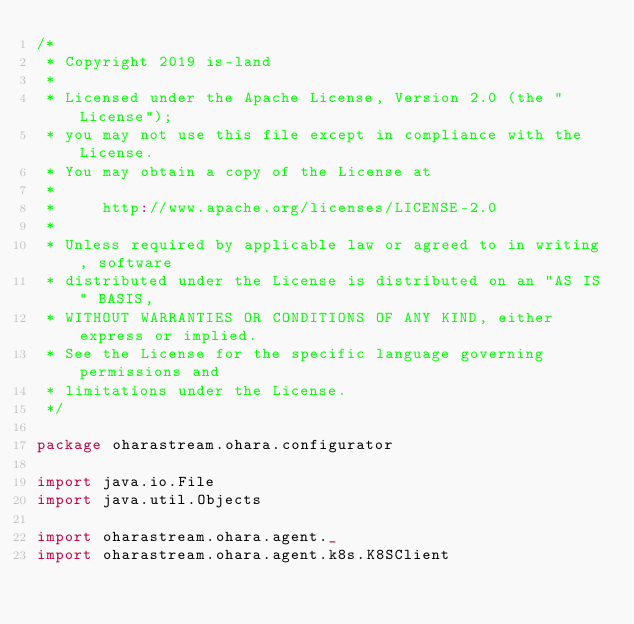<code> <loc_0><loc_0><loc_500><loc_500><_Scala_>/*
 * Copyright 2019 is-land
 *
 * Licensed under the Apache License, Version 2.0 (the "License");
 * you may not use this file except in compliance with the License.
 * You may obtain a copy of the License at
 *
 *     http://www.apache.org/licenses/LICENSE-2.0
 *
 * Unless required by applicable law or agreed to in writing, software
 * distributed under the License is distributed on an "AS IS" BASIS,
 * WITHOUT WARRANTIES OR CONDITIONS OF ANY KIND, either express or implied.
 * See the License for the specific language governing permissions and
 * limitations under the License.
 */

package oharastream.ohara.configurator

import java.io.File
import java.util.Objects

import oharastream.ohara.agent._
import oharastream.ohara.agent.k8s.K8SClient</code> 